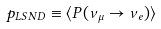<formula> <loc_0><loc_0><loc_500><loc_500>p _ { L S N D } \equiv \langle P ( \nu _ { \mu } \rightarrow \nu _ { e } ) \rangle</formula> 